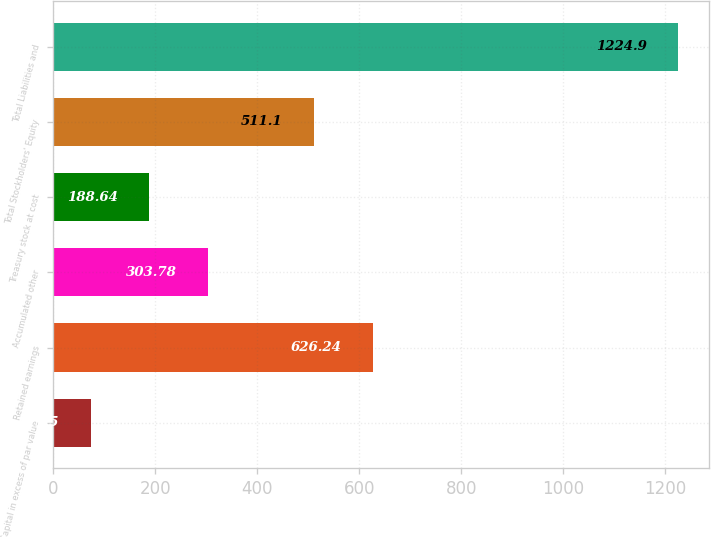Convert chart. <chart><loc_0><loc_0><loc_500><loc_500><bar_chart><fcel>Capital in excess of par value<fcel>Retained earnings<fcel>Accumulated other<fcel>Treasury stock at cost<fcel>Total Stockholders' Equity<fcel>Total Liabilities and<nl><fcel>73.5<fcel>626.24<fcel>303.78<fcel>188.64<fcel>511.1<fcel>1224.9<nl></chart> 